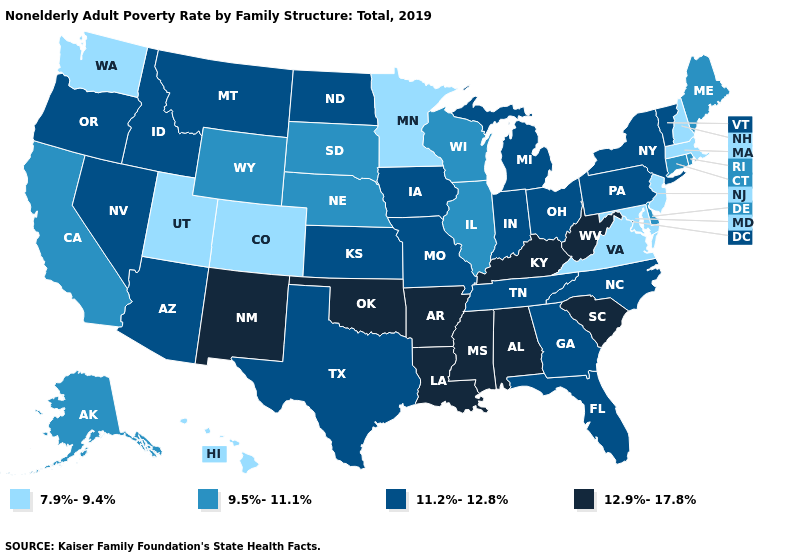Name the states that have a value in the range 11.2%-12.8%?
Concise answer only. Arizona, Florida, Georgia, Idaho, Indiana, Iowa, Kansas, Michigan, Missouri, Montana, Nevada, New York, North Carolina, North Dakota, Ohio, Oregon, Pennsylvania, Tennessee, Texas, Vermont. Does the first symbol in the legend represent the smallest category?
Short answer required. Yes. How many symbols are there in the legend?
Be succinct. 4. Among the states that border North Dakota , does Minnesota have the lowest value?
Short answer required. Yes. What is the value of Minnesota?
Short answer required. 7.9%-9.4%. What is the value of Iowa?
Be succinct. 11.2%-12.8%. Among the states that border Illinois , does Kentucky have the highest value?
Keep it brief. Yes. Name the states that have a value in the range 9.5%-11.1%?
Concise answer only. Alaska, California, Connecticut, Delaware, Illinois, Maine, Nebraska, Rhode Island, South Dakota, Wisconsin, Wyoming. Name the states that have a value in the range 7.9%-9.4%?
Write a very short answer. Colorado, Hawaii, Maryland, Massachusetts, Minnesota, New Hampshire, New Jersey, Utah, Virginia, Washington. Does Maryland have the lowest value in the USA?
Give a very brief answer. Yes. Does Louisiana have the highest value in the South?
Short answer required. Yes. Name the states that have a value in the range 9.5%-11.1%?
Give a very brief answer. Alaska, California, Connecticut, Delaware, Illinois, Maine, Nebraska, Rhode Island, South Dakota, Wisconsin, Wyoming. What is the value of Texas?
Answer briefly. 11.2%-12.8%. Among the states that border Tennessee , does Virginia have the lowest value?
Give a very brief answer. Yes. Does Wisconsin have the highest value in the MidWest?
Quick response, please. No. 